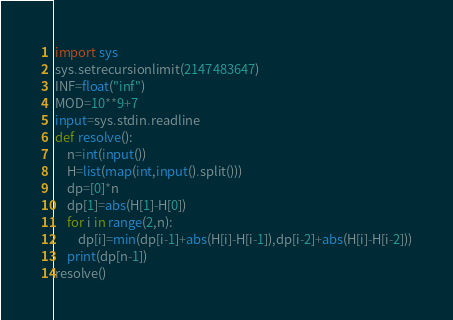<code> <loc_0><loc_0><loc_500><loc_500><_Python_>import sys
sys.setrecursionlimit(2147483647)
INF=float("inf")
MOD=10**9+7
input=sys.stdin.readline
def resolve():
    n=int(input())
    H=list(map(int,input().split()))
    dp=[0]*n
    dp[1]=abs(H[1]-H[0])
    for i in range(2,n):
        dp[i]=min(dp[i-1]+abs(H[i]-H[i-1]),dp[i-2]+abs(H[i]-H[i-2]))
    print(dp[n-1])
resolve()</code> 